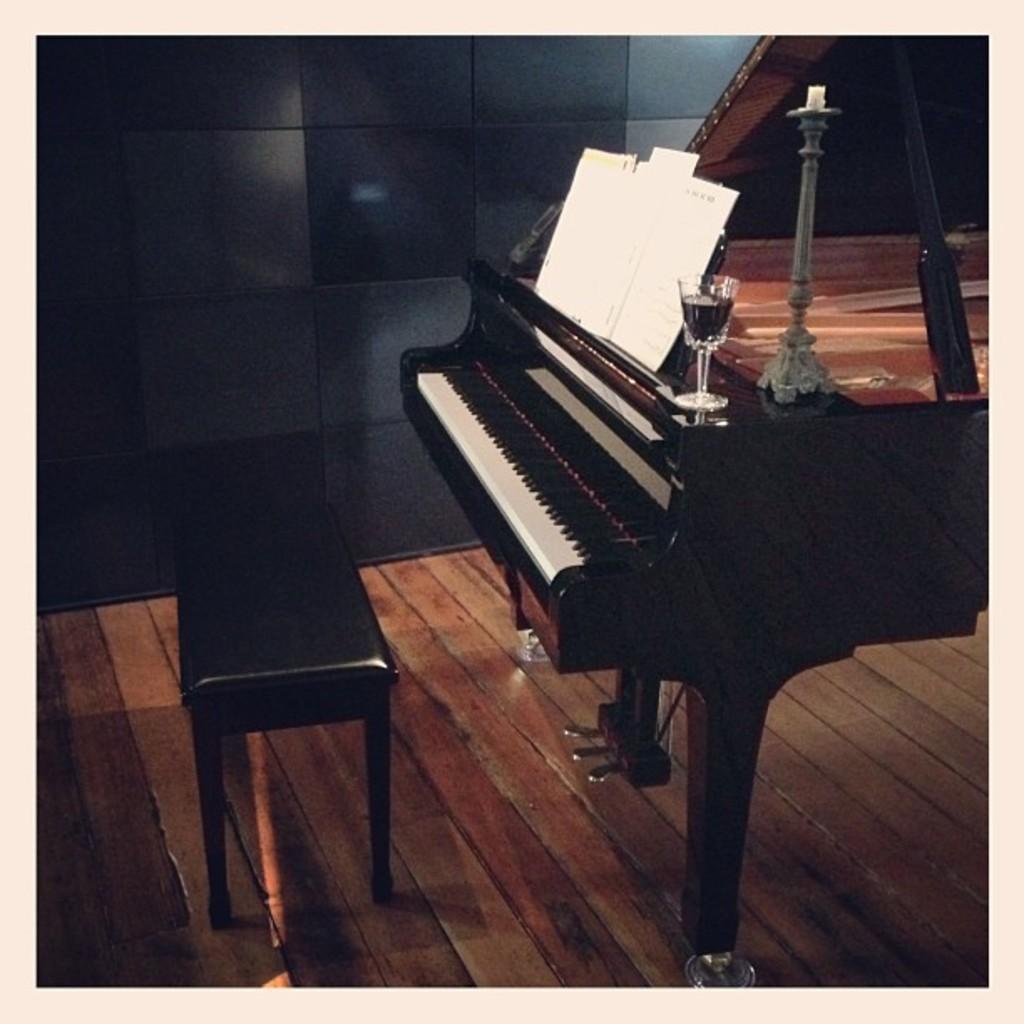In one or two sentences, can you explain what this image depicts? This picture is clicked inside the room. Here, we see a musical instrument which look like keyboard. On top of it, we see a glass containing liquid in it. Beside that, we see a black color bench and on background, we see black wall. 